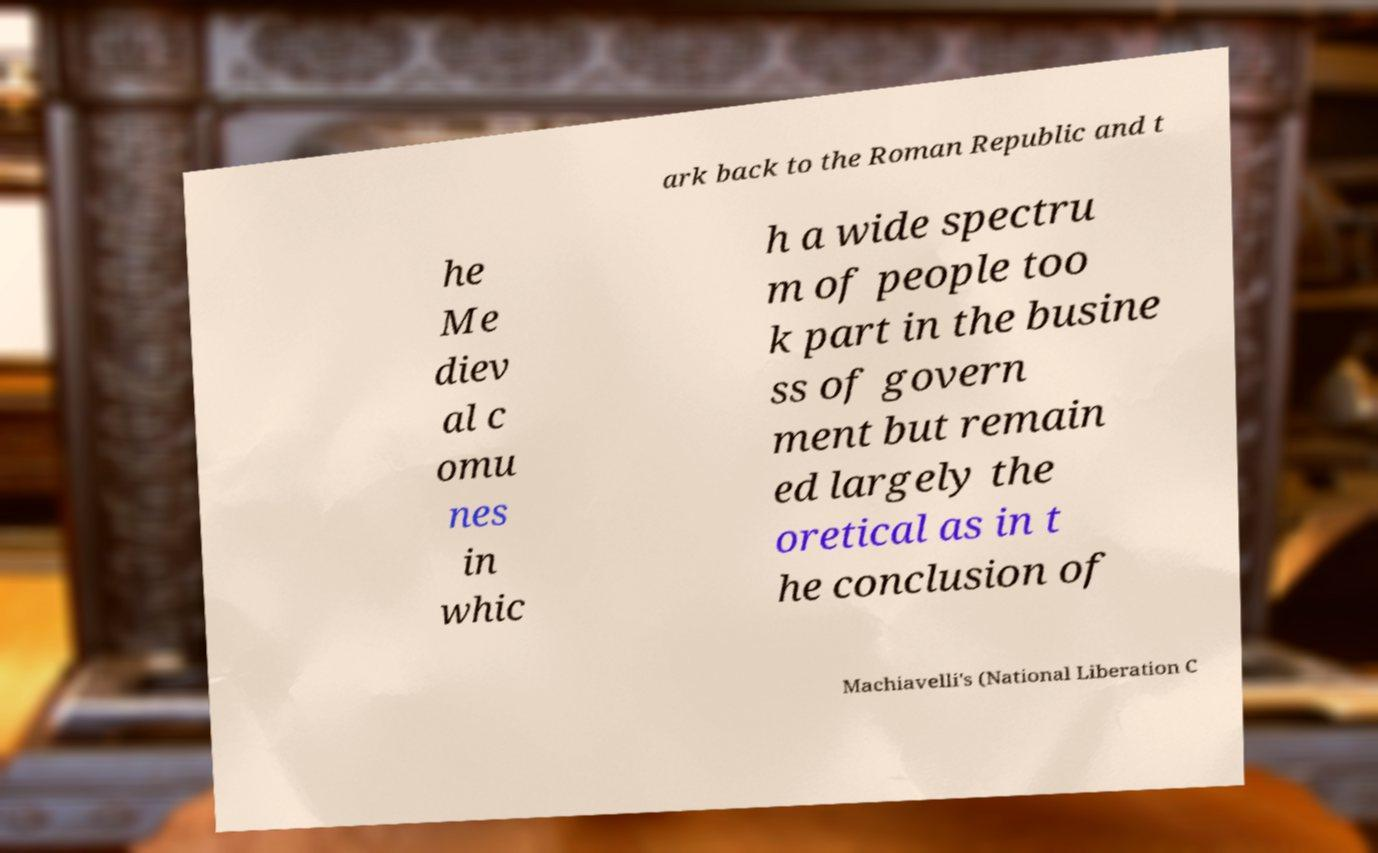Could you extract and type out the text from this image? ark back to the Roman Republic and t he Me diev al c omu nes in whic h a wide spectru m of people too k part in the busine ss of govern ment but remain ed largely the oretical as in t he conclusion of Machiavelli's (National Liberation C 